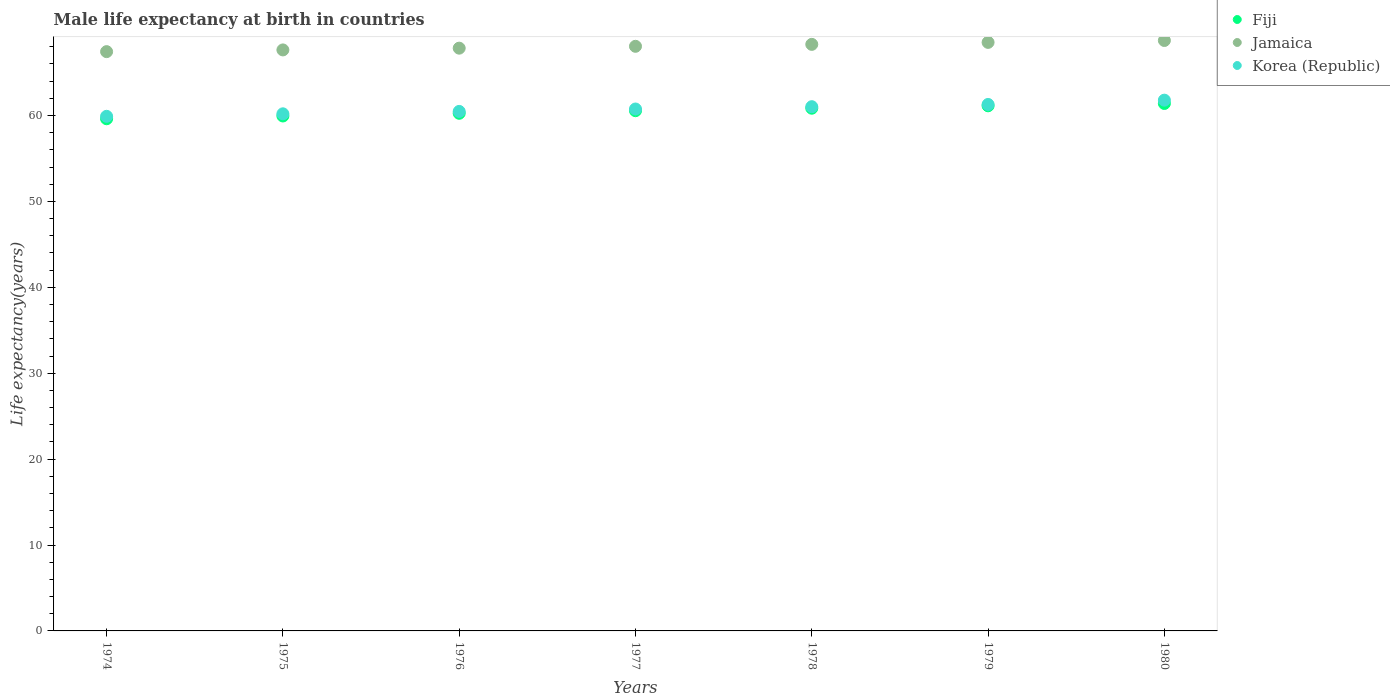What is the male life expectancy at birth in Jamaica in 1980?
Keep it short and to the point. 68.73. Across all years, what is the maximum male life expectancy at birth in Korea (Republic)?
Provide a short and direct response. 61.78. Across all years, what is the minimum male life expectancy at birth in Fiji?
Offer a very short reply. 59.62. In which year was the male life expectancy at birth in Fiji minimum?
Provide a short and direct response. 1974. What is the total male life expectancy at birth in Korea (Republic) in the graph?
Your answer should be very brief. 425.39. What is the difference between the male life expectancy at birth in Fiji in 1974 and that in 1980?
Provide a succinct answer. -1.78. What is the difference between the male life expectancy at birth in Fiji in 1979 and the male life expectancy at birth in Jamaica in 1974?
Your response must be concise. -6.3. What is the average male life expectancy at birth in Korea (Republic) per year?
Keep it short and to the point. 60.77. In the year 1974, what is the difference between the male life expectancy at birth in Korea (Republic) and male life expectancy at birth in Jamaica?
Keep it short and to the point. -7.53. In how many years, is the male life expectancy at birth in Korea (Republic) greater than 8 years?
Give a very brief answer. 7. What is the ratio of the male life expectancy at birth in Jamaica in 1976 to that in 1979?
Your answer should be very brief. 0.99. What is the difference between the highest and the second highest male life expectancy at birth in Fiji?
Ensure brevity in your answer.  0.27. What is the difference between the highest and the lowest male life expectancy at birth in Korea (Republic)?
Your answer should be very brief. 1.88. Is the sum of the male life expectancy at birth in Fiji in 1975 and 1978 greater than the maximum male life expectancy at birth in Korea (Republic) across all years?
Your response must be concise. Yes. Is it the case that in every year, the sum of the male life expectancy at birth in Korea (Republic) and male life expectancy at birth in Jamaica  is greater than the male life expectancy at birth in Fiji?
Make the answer very short. Yes. Does the male life expectancy at birth in Fiji monotonically increase over the years?
Provide a short and direct response. Yes. Is the male life expectancy at birth in Korea (Republic) strictly greater than the male life expectancy at birth in Jamaica over the years?
Ensure brevity in your answer.  No. How many dotlines are there?
Your answer should be compact. 3. What is the difference between two consecutive major ticks on the Y-axis?
Your response must be concise. 10. Does the graph contain any zero values?
Offer a terse response. No. Does the graph contain grids?
Provide a succinct answer. No. What is the title of the graph?
Ensure brevity in your answer.  Male life expectancy at birth in countries. What is the label or title of the Y-axis?
Ensure brevity in your answer.  Life expectancy(years). What is the Life expectancy(years) of Fiji in 1974?
Ensure brevity in your answer.  59.62. What is the Life expectancy(years) in Jamaica in 1974?
Provide a short and direct response. 67.43. What is the Life expectancy(years) of Korea (Republic) in 1974?
Keep it short and to the point. 59.9. What is the Life expectancy(years) of Fiji in 1975?
Offer a terse response. 59.94. What is the Life expectancy(years) of Jamaica in 1975?
Your answer should be very brief. 67.63. What is the Life expectancy(years) in Korea (Republic) in 1975?
Provide a short and direct response. 60.19. What is the Life expectancy(years) in Fiji in 1976?
Your response must be concise. 60.25. What is the Life expectancy(years) in Jamaica in 1976?
Provide a succinct answer. 67.83. What is the Life expectancy(years) of Korea (Republic) in 1976?
Offer a very short reply. 60.47. What is the Life expectancy(years) of Fiji in 1977?
Keep it short and to the point. 60.55. What is the Life expectancy(years) in Jamaica in 1977?
Your answer should be compact. 68.05. What is the Life expectancy(years) of Korea (Republic) in 1977?
Provide a short and direct response. 60.75. What is the Life expectancy(years) in Fiji in 1978?
Your answer should be very brief. 60.84. What is the Life expectancy(years) in Jamaica in 1978?
Provide a short and direct response. 68.28. What is the Life expectancy(years) of Korea (Republic) in 1978?
Your answer should be very brief. 61.02. What is the Life expectancy(years) of Fiji in 1979?
Provide a succinct answer. 61.12. What is the Life expectancy(years) of Jamaica in 1979?
Offer a terse response. 68.5. What is the Life expectancy(years) in Korea (Republic) in 1979?
Provide a succinct answer. 61.28. What is the Life expectancy(years) in Fiji in 1980?
Ensure brevity in your answer.  61.39. What is the Life expectancy(years) of Jamaica in 1980?
Provide a succinct answer. 68.73. What is the Life expectancy(years) in Korea (Republic) in 1980?
Your response must be concise. 61.78. Across all years, what is the maximum Life expectancy(years) of Fiji?
Offer a terse response. 61.39. Across all years, what is the maximum Life expectancy(years) of Jamaica?
Offer a terse response. 68.73. Across all years, what is the maximum Life expectancy(years) in Korea (Republic)?
Keep it short and to the point. 61.78. Across all years, what is the minimum Life expectancy(years) of Fiji?
Provide a short and direct response. 59.62. Across all years, what is the minimum Life expectancy(years) of Jamaica?
Give a very brief answer. 67.43. Across all years, what is the minimum Life expectancy(years) in Korea (Republic)?
Give a very brief answer. 59.9. What is the total Life expectancy(years) in Fiji in the graph?
Your answer should be compact. 423.72. What is the total Life expectancy(years) of Jamaica in the graph?
Keep it short and to the point. 476.44. What is the total Life expectancy(years) of Korea (Republic) in the graph?
Your answer should be very brief. 425.39. What is the difference between the Life expectancy(years) of Fiji in 1974 and that in 1975?
Provide a succinct answer. -0.32. What is the difference between the Life expectancy(years) of Korea (Republic) in 1974 and that in 1975?
Your response must be concise. -0.29. What is the difference between the Life expectancy(years) of Fiji in 1974 and that in 1976?
Make the answer very short. -0.64. What is the difference between the Life expectancy(years) of Jamaica in 1974 and that in 1976?
Your response must be concise. -0.41. What is the difference between the Life expectancy(years) in Korea (Republic) in 1974 and that in 1976?
Your answer should be compact. -0.57. What is the difference between the Life expectancy(years) in Fiji in 1974 and that in 1977?
Offer a very short reply. -0.94. What is the difference between the Life expectancy(years) of Jamaica in 1974 and that in 1977?
Provide a succinct answer. -0.62. What is the difference between the Life expectancy(years) in Korea (Republic) in 1974 and that in 1977?
Give a very brief answer. -0.85. What is the difference between the Life expectancy(years) of Fiji in 1974 and that in 1978?
Offer a very short reply. -1.23. What is the difference between the Life expectancy(years) of Jamaica in 1974 and that in 1978?
Give a very brief answer. -0.85. What is the difference between the Life expectancy(years) of Korea (Republic) in 1974 and that in 1978?
Give a very brief answer. -1.12. What is the difference between the Life expectancy(years) of Fiji in 1974 and that in 1979?
Make the answer very short. -1.51. What is the difference between the Life expectancy(years) of Jamaica in 1974 and that in 1979?
Provide a succinct answer. -1.08. What is the difference between the Life expectancy(years) in Korea (Republic) in 1974 and that in 1979?
Offer a terse response. -1.38. What is the difference between the Life expectancy(years) in Fiji in 1974 and that in 1980?
Ensure brevity in your answer.  -1.78. What is the difference between the Life expectancy(years) of Jamaica in 1974 and that in 1980?
Your answer should be very brief. -1.3. What is the difference between the Life expectancy(years) of Korea (Republic) in 1974 and that in 1980?
Make the answer very short. -1.88. What is the difference between the Life expectancy(years) of Fiji in 1975 and that in 1976?
Make the answer very short. -0.31. What is the difference between the Life expectancy(years) in Jamaica in 1975 and that in 1976?
Keep it short and to the point. -0.2. What is the difference between the Life expectancy(years) of Korea (Republic) in 1975 and that in 1976?
Provide a short and direct response. -0.28. What is the difference between the Life expectancy(years) in Fiji in 1975 and that in 1977?
Offer a very short reply. -0.61. What is the difference between the Life expectancy(years) in Jamaica in 1975 and that in 1977?
Your response must be concise. -0.42. What is the difference between the Life expectancy(years) of Korea (Republic) in 1975 and that in 1977?
Your answer should be compact. -0.56. What is the difference between the Life expectancy(years) of Fiji in 1975 and that in 1978?
Keep it short and to the point. -0.9. What is the difference between the Life expectancy(years) in Jamaica in 1975 and that in 1978?
Offer a terse response. -0.65. What is the difference between the Life expectancy(years) in Korea (Republic) in 1975 and that in 1978?
Make the answer very short. -0.83. What is the difference between the Life expectancy(years) in Fiji in 1975 and that in 1979?
Your answer should be compact. -1.19. What is the difference between the Life expectancy(years) in Jamaica in 1975 and that in 1979?
Your answer should be very brief. -0.88. What is the difference between the Life expectancy(years) of Korea (Republic) in 1975 and that in 1979?
Your answer should be very brief. -1.09. What is the difference between the Life expectancy(years) of Fiji in 1975 and that in 1980?
Provide a succinct answer. -1.46. What is the difference between the Life expectancy(years) in Jamaica in 1975 and that in 1980?
Make the answer very short. -1.1. What is the difference between the Life expectancy(years) in Korea (Republic) in 1975 and that in 1980?
Your answer should be very brief. -1.59. What is the difference between the Life expectancy(years) of Fiji in 1976 and that in 1977?
Ensure brevity in your answer.  -0.3. What is the difference between the Life expectancy(years) of Jamaica in 1976 and that in 1977?
Provide a short and direct response. -0.22. What is the difference between the Life expectancy(years) of Korea (Republic) in 1976 and that in 1977?
Provide a short and direct response. -0.28. What is the difference between the Life expectancy(years) in Fiji in 1976 and that in 1978?
Offer a terse response. -0.59. What is the difference between the Life expectancy(years) of Jamaica in 1976 and that in 1978?
Offer a terse response. -0.44. What is the difference between the Life expectancy(years) of Korea (Republic) in 1976 and that in 1978?
Keep it short and to the point. -0.55. What is the difference between the Life expectancy(years) in Fiji in 1976 and that in 1979?
Ensure brevity in your answer.  -0.87. What is the difference between the Life expectancy(years) in Jamaica in 1976 and that in 1979?
Your answer should be very brief. -0.67. What is the difference between the Life expectancy(years) of Korea (Republic) in 1976 and that in 1979?
Provide a short and direct response. -0.81. What is the difference between the Life expectancy(years) in Fiji in 1976 and that in 1980?
Make the answer very short. -1.14. What is the difference between the Life expectancy(years) of Jamaica in 1976 and that in 1980?
Your answer should be very brief. -0.89. What is the difference between the Life expectancy(years) in Korea (Republic) in 1976 and that in 1980?
Offer a terse response. -1.31. What is the difference between the Life expectancy(years) of Fiji in 1977 and that in 1978?
Ensure brevity in your answer.  -0.29. What is the difference between the Life expectancy(years) in Jamaica in 1977 and that in 1978?
Your answer should be compact. -0.23. What is the difference between the Life expectancy(years) in Korea (Republic) in 1977 and that in 1978?
Offer a terse response. -0.27. What is the difference between the Life expectancy(years) of Fiji in 1977 and that in 1979?
Provide a succinct answer. -0.57. What is the difference between the Life expectancy(years) in Jamaica in 1977 and that in 1979?
Provide a succinct answer. -0.46. What is the difference between the Life expectancy(years) of Korea (Republic) in 1977 and that in 1979?
Keep it short and to the point. -0.53. What is the difference between the Life expectancy(years) of Fiji in 1977 and that in 1980?
Offer a very short reply. -0.84. What is the difference between the Life expectancy(years) of Jamaica in 1977 and that in 1980?
Ensure brevity in your answer.  -0.68. What is the difference between the Life expectancy(years) of Korea (Republic) in 1977 and that in 1980?
Your answer should be very brief. -1.03. What is the difference between the Life expectancy(years) of Fiji in 1978 and that in 1979?
Your answer should be very brief. -0.28. What is the difference between the Life expectancy(years) in Jamaica in 1978 and that in 1979?
Offer a terse response. -0.23. What is the difference between the Life expectancy(years) of Korea (Republic) in 1978 and that in 1979?
Your response must be concise. -0.26. What is the difference between the Life expectancy(years) of Fiji in 1978 and that in 1980?
Provide a short and direct response. -0.55. What is the difference between the Life expectancy(years) in Jamaica in 1978 and that in 1980?
Your answer should be compact. -0.45. What is the difference between the Life expectancy(years) in Korea (Republic) in 1978 and that in 1980?
Give a very brief answer. -0.76. What is the difference between the Life expectancy(years) of Fiji in 1979 and that in 1980?
Give a very brief answer. -0.27. What is the difference between the Life expectancy(years) of Jamaica in 1979 and that in 1980?
Ensure brevity in your answer.  -0.22. What is the difference between the Life expectancy(years) in Fiji in 1974 and the Life expectancy(years) in Jamaica in 1975?
Offer a very short reply. -8.01. What is the difference between the Life expectancy(years) of Fiji in 1974 and the Life expectancy(years) of Korea (Republic) in 1975?
Ensure brevity in your answer.  -0.57. What is the difference between the Life expectancy(years) of Jamaica in 1974 and the Life expectancy(years) of Korea (Republic) in 1975?
Offer a very short reply. 7.24. What is the difference between the Life expectancy(years) in Fiji in 1974 and the Life expectancy(years) in Jamaica in 1976?
Your answer should be very brief. -8.22. What is the difference between the Life expectancy(years) of Fiji in 1974 and the Life expectancy(years) of Korea (Republic) in 1976?
Make the answer very short. -0.85. What is the difference between the Life expectancy(years) in Jamaica in 1974 and the Life expectancy(years) in Korea (Republic) in 1976?
Your answer should be very brief. 6.96. What is the difference between the Life expectancy(years) in Fiji in 1974 and the Life expectancy(years) in Jamaica in 1977?
Keep it short and to the point. -8.43. What is the difference between the Life expectancy(years) in Fiji in 1974 and the Life expectancy(years) in Korea (Republic) in 1977?
Keep it short and to the point. -1.14. What is the difference between the Life expectancy(years) of Jamaica in 1974 and the Life expectancy(years) of Korea (Republic) in 1977?
Your answer should be compact. 6.68. What is the difference between the Life expectancy(years) of Fiji in 1974 and the Life expectancy(years) of Jamaica in 1978?
Give a very brief answer. -8.66. What is the difference between the Life expectancy(years) in Fiji in 1974 and the Life expectancy(years) in Korea (Republic) in 1978?
Your answer should be compact. -1.41. What is the difference between the Life expectancy(years) in Jamaica in 1974 and the Life expectancy(years) in Korea (Republic) in 1978?
Provide a succinct answer. 6.41. What is the difference between the Life expectancy(years) of Fiji in 1974 and the Life expectancy(years) of Jamaica in 1979?
Your response must be concise. -8.89. What is the difference between the Life expectancy(years) in Fiji in 1974 and the Life expectancy(years) in Korea (Republic) in 1979?
Provide a succinct answer. -1.67. What is the difference between the Life expectancy(years) in Jamaica in 1974 and the Life expectancy(years) in Korea (Republic) in 1979?
Your answer should be compact. 6.15. What is the difference between the Life expectancy(years) in Fiji in 1974 and the Life expectancy(years) in Jamaica in 1980?
Your answer should be very brief. -9.11. What is the difference between the Life expectancy(years) of Fiji in 1974 and the Life expectancy(years) of Korea (Republic) in 1980?
Provide a succinct answer. -2.17. What is the difference between the Life expectancy(years) in Jamaica in 1974 and the Life expectancy(years) in Korea (Republic) in 1980?
Give a very brief answer. 5.65. What is the difference between the Life expectancy(years) in Fiji in 1975 and the Life expectancy(years) in Jamaica in 1976?
Keep it short and to the point. -7.89. What is the difference between the Life expectancy(years) of Fiji in 1975 and the Life expectancy(years) of Korea (Republic) in 1976?
Provide a short and direct response. -0.53. What is the difference between the Life expectancy(years) in Jamaica in 1975 and the Life expectancy(years) in Korea (Republic) in 1976?
Provide a succinct answer. 7.16. What is the difference between the Life expectancy(years) of Fiji in 1975 and the Life expectancy(years) of Jamaica in 1977?
Offer a terse response. -8.11. What is the difference between the Life expectancy(years) of Fiji in 1975 and the Life expectancy(years) of Korea (Republic) in 1977?
Give a very brief answer. -0.81. What is the difference between the Life expectancy(years) of Jamaica in 1975 and the Life expectancy(years) of Korea (Republic) in 1977?
Your answer should be compact. 6.88. What is the difference between the Life expectancy(years) of Fiji in 1975 and the Life expectancy(years) of Jamaica in 1978?
Keep it short and to the point. -8.34. What is the difference between the Life expectancy(years) of Fiji in 1975 and the Life expectancy(years) of Korea (Republic) in 1978?
Make the answer very short. -1.08. What is the difference between the Life expectancy(years) in Jamaica in 1975 and the Life expectancy(years) in Korea (Republic) in 1978?
Provide a succinct answer. 6.61. What is the difference between the Life expectancy(years) in Fiji in 1975 and the Life expectancy(years) in Jamaica in 1979?
Provide a short and direct response. -8.57. What is the difference between the Life expectancy(years) of Fiji in 1975 and the Life expectancy(years) of Korea (Republic) in 1979?
Give a very brief answer. -1.34. What is the difference between the Life expectancy(years) of Jamaica in 1975 and the Life expectancy(years) of Korea (Republic) in 1979?
Provide a short and direct response. 6.35. What is the difference between the Life expectancy(years) in Fiji in 1975 and the Life expectancy(years) in Jamaica in 1980?
Ensure brevity in your answer.  -8.79. What is the difference between the Life expectancy(years) of Fiji in 1975 and the Life expectancy(years) of Korea (Republic) in 1980?
Offer a very short reply. -1.84. What is the difference between the Life expectancy(years) in Jamaica in 1975 and the Life expectancy(years) in Korea (Republic) in 1980?
Your response must be concise. 5.85. What is the difference between the Life expectancy(years) of Fiji in 1976 and the Life expectancy(years) of Jamaica in 1977?
Ensure brevity in your answer.  -7.8. What is the difference between the Life expectancy(years) of Fiji in 1976 and the Life expectancy(years) of Korea (Republic) in 1977?
Ensure brevity in your answer.  -0.5. What is the difference between the Life expectancy(years) in Jamaica in 1976 and the Life expectancy(years) in Korea (Republic) in 1977?
Provide a succinct answer. 7.08. What is the difference between the Life expectancy(years) in Fiji in 1976 and the Life expectancy(years) in Jamaica in 1978?
Offer a terse response. -8.02. What is the difference between the Life expectancy(years) in Fiji in 1976 and the Life expectancy(years) in Korea (Republic) in 1978?
Your answer should be compact. -0.77. What is the difference between the Life expectancy(years) of Jamaica in 1976 and the Life expectancy(years) of Korea (Republic) in 1978?
Make the answer very short. 6.81. What is the difference between the Life expectancy(years) of Fiji in 1976 and the Life expectancy(years) of Jamaica in 1979?
Provide a succinct answer. -8.25. What is the difference between the Life expectancy(years) in Fiji in 1976 and the Life expectancy(years) in Korea (Republic) in 1979?
Offer a terse response. -1.03. What is the difference between the Life expectancy(years) in Jamaica in 1976 and the Life expectancy(years) in Korea (Republic) in 1979?
Keep it short and to the point. 6.55. What is the difference between the Life expectancy(years) of Fiji in 1976 and the Life expectancy(years) of Jamaica in 1980?
Keep it short and to the point. -8.47. What is the difference between the Life expectancy(years) in Fiji in 1976 and the Life expectancy(years) in Korea (Republic) in 1980?
Your response must be concise. -1.53. What is the difference between the Life expectancy(years) of Jamaica in 1976 and the Life expectancy(years) of Korea (Republic) in 1980?
Provide a short and direct response. 6.05. What is the difference between the Life expectancy(years) of Fiji in 1977 and the Life expectancy(years) of Jamaica in 1978?
Offer a very short reply. -7.72. What is the difference between the Life expectancy(years) of Fiji in 1977 and the Life expectancy(years) of Korea (Republic) in 1978?
Offer a very short reply. -0.47. What is the difference between the Life expectancy(years) of Jamaica in 1977 and the Life expectancy(years) of Korea (Republic) in 1978?
Offer a very short reply. 7.03. What is the difference between the Life expectancy(years) in Fiji in 1977 and the Life expectancy(years) in Jamaica in 1979?
Make the answer very short. -7.95. What is the difference between the Life expectancy(years) in Fiji in 1977 and the Life expectancy(years) in Korea (Republic) in 1979?
Your response must be concise. -0.73. What is the difference between the Life expectancy(years) in Jamaica in 1977 and the Life expectancy(years) in Korea (Republic) in 1979?
Provide a succinct answer. 6.77. What is the difference between the Life expectancy(years) in Fiji in 1977 and the Life expectancy(years) in Jamaica in 1980?
Your answer should be compact. -8.17. What is the difference between the Life expectancy(years) of Fiji in 1977 and the Life expectancy(years) of Korea (Republic) in 1980?
Offer a very short reply. -1.23. What is the difference between the Life expectancy(years) of Jamaica in 1977 and the Life expectancy(years) of Korea (Republic) in 1980?
Give a very brief answer. 6.27. What is the difference between the Life expectancy(years) in Fiji in 1978 and the Life expectancy(years) in Jamaica in 1979?
Offer a terse response. -7.66. What is the difference between the Life expectancy(years) in Fiji in 1978 and the Life expectancy(years) in Korea (Republic) in 1979?
Your answer should be very brief. -0.44. What is the difference between the Life expectancy(years) of Jamaica in 1978 and the Life expectancy(years) of Korea (Republic) in 1979?
Ensure brevity in your answer.  7. What is the difference between the Life expectancy(years) in Fiji in 1978 and the Life expectancy(years) in Jamaica in 1980?
Ensure brevity in your answer.  -7.88. What is the difference between the Life expectancy(years) in Fiji in 1978 and the Life expectancy(years) in Korea (Republic) in 1980?
Provide a succinct answer. -0.94. What is the difference between the Life expectancy(years) of Jamaica in 1978 and the Life expectancy(years) of Korea (Republic) in 1980?
Ensure brevity in your answer.  6.5. What is the difference between the Life expectancy(years) of Fiji in 1979 and the Life expectancy(years) of Jamaica in 1980?
Your answer should be compact. -7.6. What is the difference between the Life expectancy(years) in Fiji in 1979 and the Life expectancy(years) in Korea (Republic) in 1980?
Make the answer very short. -0.66. What is the difference between the Life expectancy(years) of Jamaica in 1979 and the Life expectancy(years) of Korea (Republic) in 1980?
Your response must be concise. 6.72. What is the average Life expectancy(years) in Fiji per year?
Your answer should be very brief. 60.53. What is the average Life expectancy(years) of Jamaica per year?
Keep it short and to the point. 68.06. What is the average Life expectancy(years) in Korea (Republic) per year?
Provide a short and direct response. 60.77. In the year 1974, what is the difference between the Life expectancy(years) in Fiji and Life expectancy(years) in Jamaica?
Provide a short and direct response. -7.81. In the year 1974, what is the difference between the Life expectancy(years) of Fiji and Life expectancy(years) of Korea (Republic)?
Make the answer very short. -0.28. In the year 1974, what is the difference between the Life expectancy(years) of Jamaica and Life expectancy(years) of Korea (Republic)?
Give a very brief answer. 7.53. In the year 1975, what is the difference between the Life expectancy(years) of Fiji and Life expectancy(years) of Jamaica?
Make the answer very short. -7.69. In the year 1975, what is the difference between the Life expectancy(years) in Fiji and Life expectancy(years) in Korea (Republic)?
Make the answer very short. -0.25. In the year 1975, what is the difference between the Life expectancy(years) in Jamaica and Life expectancy(years) in Korea (Republic)?
Make the answer very short. 7.44. In the year 1976, what is the difference between the Life expectancy(years) in Fiji and Life expectancy(years) in Jamaica?
Provide a short and direct response. -7.58. In the year 1976, what is the difference between the Life expectancy(years) of Fiji and Life expectancy(years) of Korea (Republic)?
Your response must be concise. -0.22. In the year 1976, what is the difference between the Life expectancy(years) of Jamaica and Life expectancy(years) of Korea (Republic)?
Ensure brevity in your answer.  7.36. In the year 1977, what is the difference between the Life expectancy(years) of Fiji and Life expectancy(years) of Jamaica?
Your response must be concise. -7.5. In the year 1977, what is the difference between the Life expectancy(years) in Fiji and Life expectancy(years) in Korea (Republic)?
Provide a short and direct response. -0.2. In the year 1977, what is the difference between the Life expectancy(years) in Jamaica and Life expectancy(years) in Korea (Republic)?
Your answer should be very brief. 7.3. In the year 1978, what is the difference between the Life expectancy(years) of Fiji and Life expectancy(years) of Jamaica?
Give a very brief answer. -7.43. In the year 1978, what is the difference between the Life expectancy(years) in Fiji and Life expectancy(years) in Korea (Republic)?
Your answer should be compact. -0.18. In the year 1978, what is the difference between the Life expectancy(years) of Jamaica and Life expectancy(years) of Korea (Republic)?
Your response must be concise. 7.25. In the year 1979, what is the difference between the Life expectancy(years) of Fiji and Life expectancy(years) of Jamaica?
Ensure brevity in your answer.  -7.38. In the year 1979, what is the difference between the Life expectancy(years) of Fiji and Life expectancy(years) of Korea (Republic)?
Provide a short and direct response. -0.16. In the year 1979, what is the difference between the Life expectancy(years) in Jamaica and Life expectancy(years) in Korea (Republic)?
Offer a terse response. 7.22. In the year 1980, what is the difference between the Life expectancy(years) in Fiji and Life expectancy(years) in Jamaica?
Provide a short and direct response. -7.33. In the year 1980, what is the difference between the Life expectancy(years) of Fiji and Life expectancy(years) of Korea (Republic)?
Provide a succinct answer. -0.39. In the year 1980, what is the difference between the Life expectancy(years) of Jamaica and Life expectancy(years) of Korea (Republic)?
Make the answer very short. 6.95. What is the ratio of the Life expectancy(years) in Korea (Republic) in 1974 to that in 1975?
Offer a very short reply. 1. What is the ratio of the Life expectancy(years) of Jamaica in 1974 to that in 1976?
Your answer should be very brief. 0.99. What is the ratio of the Life expectancy(years) of Korea (Republic) in 1974 to that in 1976?
Provide a short and direct response. 0.99. What is the ratio of the Life expectancy(years) of Fiji in 1974 to that in 1977?
Make the answer very short. 0.98. What is the ratio of the Life expectancy(years) of Jamaica in 1974 to that in 1977?
Give a very brief answer. 0.99. What is the ratio of the Life expectancy(years) in Fiji in 1974 to that in 1978?
Provide a succinct answer. 0.98. What is the ratio of the Life expectancy(years) in Jamaica in 1974 to that in 1978?
Ensure brevity in your answer.  0.99. What is the ratio of the Life expectancy(years) in Korea (Republic) in 1974 to that in 1978?
Offer a terse response. 0.98. What is the ratio of the Life expectancy(years) in Fiji in 1974 to that in 1979?
Provide a succinct answer. 0.98. What is the ratio of the Life expectancy(years) of Jamaica in 1974 to that in 1979?
Provide a short and direct response. 0.98. What is the ratio of the Life expectancy(years) in Korea (Republic) in 1974 to that in 1979?
Give a very brief answer. 0.98. What is the ratio of the Life expectancy(years) in Fiji in 1974 to that in 1980?
Offer a very short reply. 0.97. What is the ratio of the Life expectancy(years) in Jamaica in 1974 to that in 1980?
Make the answer very short. 0.98. What is the ratio of the Life expectancy(years) in Korea (Republic) in 1974 to that in 1980?
Provide a succinct answer. 0.97. What is the ratio of the Life expectancy(years) of Fiji in 1975 to that in 1976?
Make the answer very short. 0.99. What is the ratio of the Life expectancy(years) of Jamaica in 1975 to that in 1976?
Ensure brevity in your answer.  1. What is the ratio of the Life expectancy(years) of Fiji in 1975 to that in 1978?
Keep it short and to the point. 0.99. What is the ratio of the Life expectancy(years) of Jamaica in 1975 to that in 1978?
Keep it short and to the point. 0.99. What is the ratio of the Life expectancy(years) of Korea (Republic) in 1975 to that in 1978?
Make the answer very short. 0.99. What is the ratio of the Life expectancy(years) of Fiji in 1975 to that in 1979?
Your response must be concise. 0.98. What is the ratio of the Life expectancy(years) of Jamaica in 1975 to that in 1979?
Your response must be concise. 0.99. What is the ratio of the Life expectancy(years) in Korea (Republic) in 1975 to that in 1979?
Make the answer very short. 0.98. What is the ratio of the Life expectancy(years) in Fiji in 1975 to that in 1980?
Your answer should be very brief. 0.98. What is the ratio of the Life expectancy(years) in Korea (Republic) in 1975 to that in 1980?
Offer a very short reply. 0.97. What is the ratio of the Life expectancy(years) of Korea (Republic) in 1976 to that in 1977?
Offer a very short reply. 1. What is the ratio of the Life expectancy(years) in Fiji in 1976 to that in 1978?
Ensure brevity in your answer.  0.99. What is the ratio of the Life expectancy(years) of Korea (Republic) in 1976 to that in 1978?
Give a very brief answer. 0.99. What is the ratio of the Life expectancy(years) in Fiji in 1976 to that in 1979?
Your answer should be very brief. 0.99. What is the ratio of the Life expectancy(years) of Jamaica in 1976 to that in 1979?
Keep it short and to the point. 0.99. What is the ratio of the Life expectancy(years) in Korea (Republic) in 1976 to that in 1979?
Offer a terse response. 0.99. What is the ratio of the Life expectancy(years) in Fiji in 1976 to that in 1980?
Keep it short and to the point. 0.98. What is the ratio of the Life expectancy(years) of Korea (Republic) in 1976 to that in 1980?
Offer a very short reply. 0.98. What is the ratio of the Life expectancy(years) of Jamaica in 1977 to that in 1978?
Keep it short and to the point. 1. What is the ratio of the Life expectancy(years) in Fiji in 1977 to that in 1980?
Offer a very short reply. 0.99. What is the ratio of the Life expectancy(years) in Korea (Republic) in 1977 to that in 1980?
Your answer should be very brief. 0.98. What is the ratio of the Life expectancy(years) in Fiji in 1978 to that in 1979?
Offer a terse response. 1. What is the ratio of the Life expectancy(years) of Korea (Republic) in 1978 to that in 1979?
Provide a succinct answer. 1. What is the ratio of the Life expectancy(years) in Fiji in 1978 to that in 1980?
Offer a very short reply. 0.99. What is the ratio of the Life expectancy(years) in Jamaica in 1978 to that in 1980?
Offer a terse response. 0.99. What is the ratio of the Life expectancy(years) of Korea (Republic) in 1978 to that in 1980?
Provide a succinct answer. 0.99. What is the ratio of the Life expectancy(years) of Fiji in 1979 to that in 1980?
Offer a terse response. 1. What is the ratio of the Life expectancy(years) of Jamaica in 1979 to that in 1980?
Offer a very short reply. 1. What is the difference between the highest and the second highest Life expectancy(years) of Fiji?
Give a very brief answer. 0.27. What is the difference between the highest and the second highest Life expectancy(years) of Jamaica?
Keep it short and to the point. 0.22. What is the difference between the highest and the lowest Life expectancy(years) in Fiji?
Your response must be concise. 1.78. What is the difference between the highest and the lowest Life expectancy(years) of Jamaica?
Your answer should be compact. 1.3. What is the difference between the highest and the lowest Life expectancy(years) of Korea (Republic)?
Make the answer very short. 1.88. 